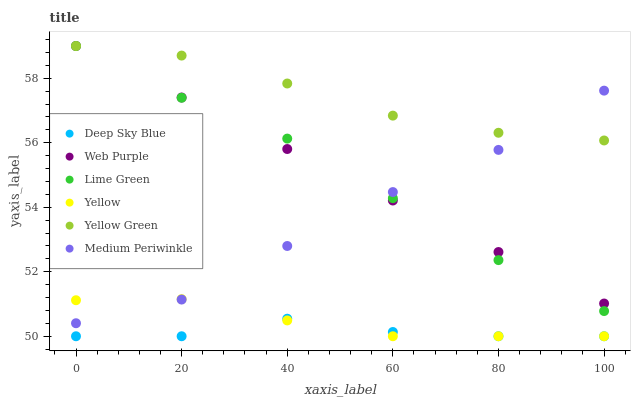Does Deep Sky Blue have the minimum area under the curve?
Answer yes or no. Yes. Does Yellow Green have the maximum area under the curve?
Answer yes or no. Yes. Does Medium Periwinkle have the minimum area under the curve?
Answer yes or no. No. Does Medium Periwinkle have the maximum area under the curve?
Answer yes or no. No. Is Web Purple the smoothest?
Answer yes or no. Yes. Is Deep Sky Blue the roughest?
Answer yes or no. Yes. Is Medium Periwinkle the smoothest?
Answer yes or no. No. Is Medium Periwinkle the roughest?
Answer yes or no. No. Does Yellow have the lowest value?
Answer yes or no. Yes. Does Medium Periwinkle have the lowest value?
Answer yes or no. No. Does Lime Green have the highest value?
Answer yes or no. Yes. Does Medium Periwinkle have the highest value?
Answer yes or no. No. Is Deep Sky Blue less than Yellow Green?
Answer yes or no. Yes. Is Web Purple greater than Deep Sky Blue?
Answer yes or no. Yes. Does Yellow intersect Medium Periwinkle?
Answer yes or no. Yes. Is Yellow less than Medium Periwinkle?
Answer yes or no. No. Is Yellow greater than Medium Periwinkle?
Answer yes or no. No. Does Deep Sky Blue intersect Yellow Green?
Answer yes or no. No. 